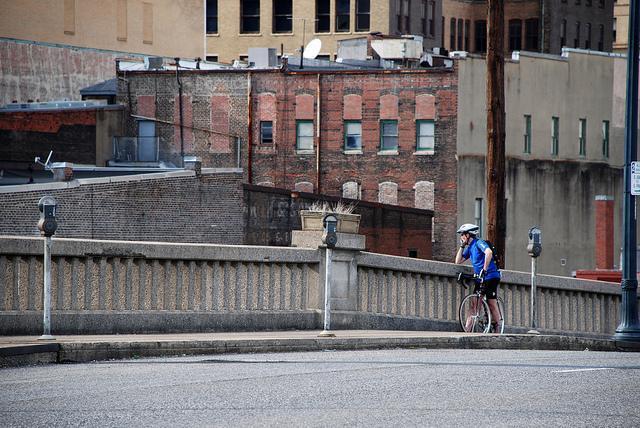How many people are in the photo?
Give a very brief answer. 1. 